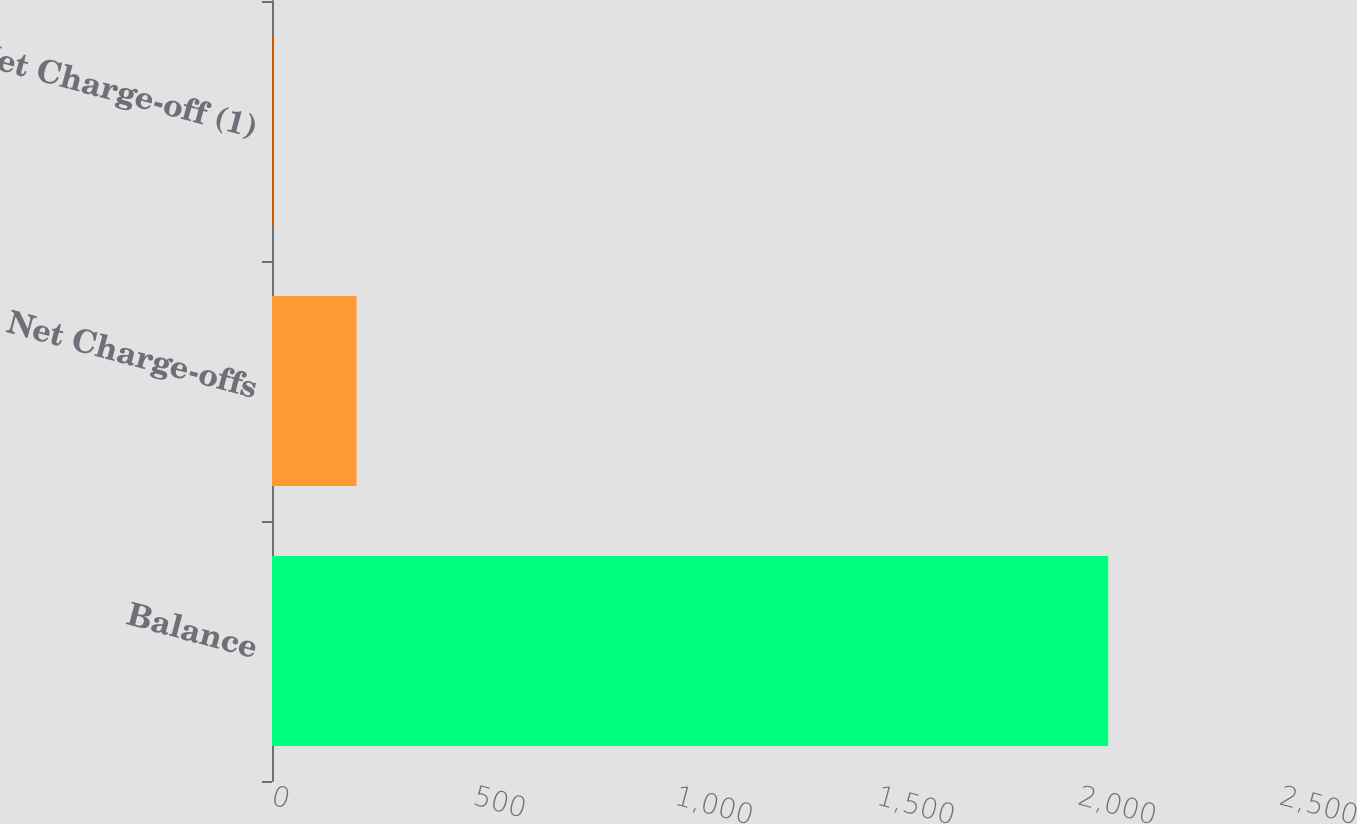Convert chart to OTSL. <chart><loc_0><loc_0><loc_500><loc_500><bar_chart><fcel>Balance<fcel>Net Charge-offs<fcel>Net Charge-off (1)<nl><fcel>2074<fcel>209.79<fcel>2.66<nl></chart> 